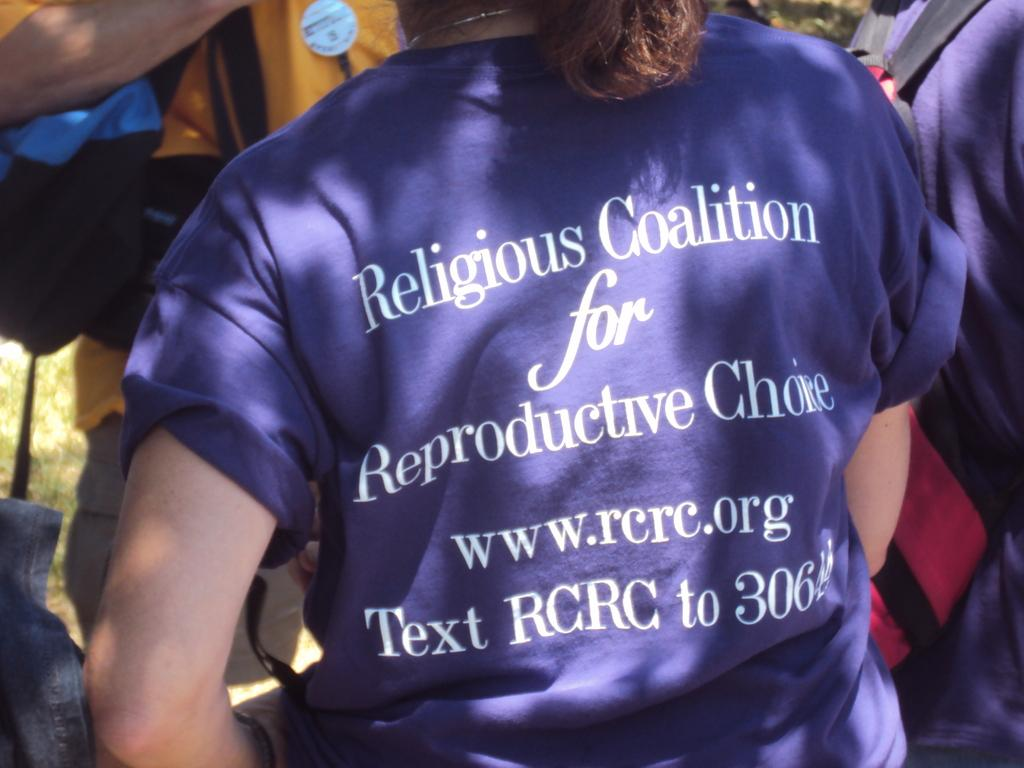<image>
Share a concise interpretation of the image provided. a person with a shirt on that says religious coalition 